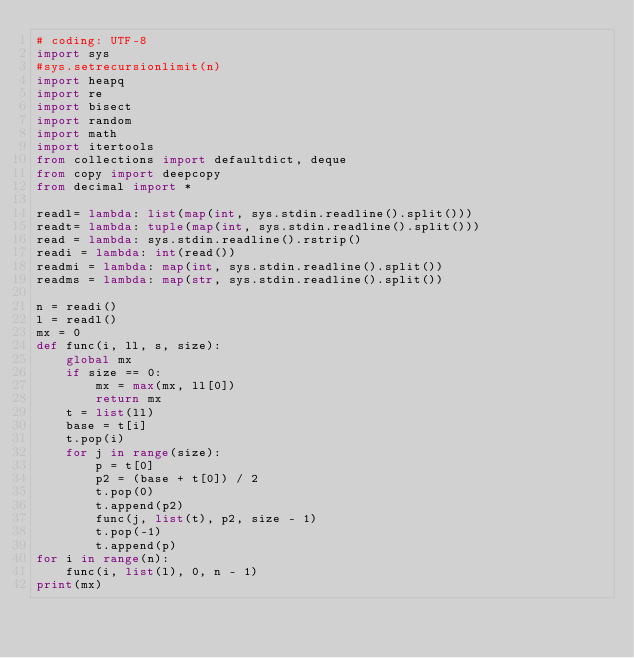Convert code to text. <code><loc_0><loc_0><loc_500><loc_500><_Python_># coding: UTF-8
import sys
#sys.setrecursionlimit(n)
import heapq
import re
import bisect
import random
import math
import itertools
from collections import defaultdict, deque
from copy import deepcopy
from decimal import *

readl= lambda: list(map(int, sys.stdin.readline().split()))
readt= lambda: tuple(map(int, sys.stdin.readline().split()))
read = lambda: sys.stdin.readline().rstrip()
readi = lambda: int(read())
readmi = lambda: map(int, sys.stdin.readline().split())
readms = lambda: map(str, sys.stdin.readline().split())

n = readi()
l = readl()
mx = 0
def func(i, ll, s, size):
    global mx
    if size == 0:
        mx = max(mx, ll[0])
        return mx
    t = list(ll)
    base = t[i]
    t.pop(i)
    for j in range(size):
        p = t[0]
        p2 = (base + t[0]) / 2
        t.pop(0)
        t.append(p2)
        func(j, list(t), p2, size - 1)
        t.pop(-1)
        t.append(p)
for i in range(n):
    func(i, list(l), 0, n - 1)
print(mx)</code> 